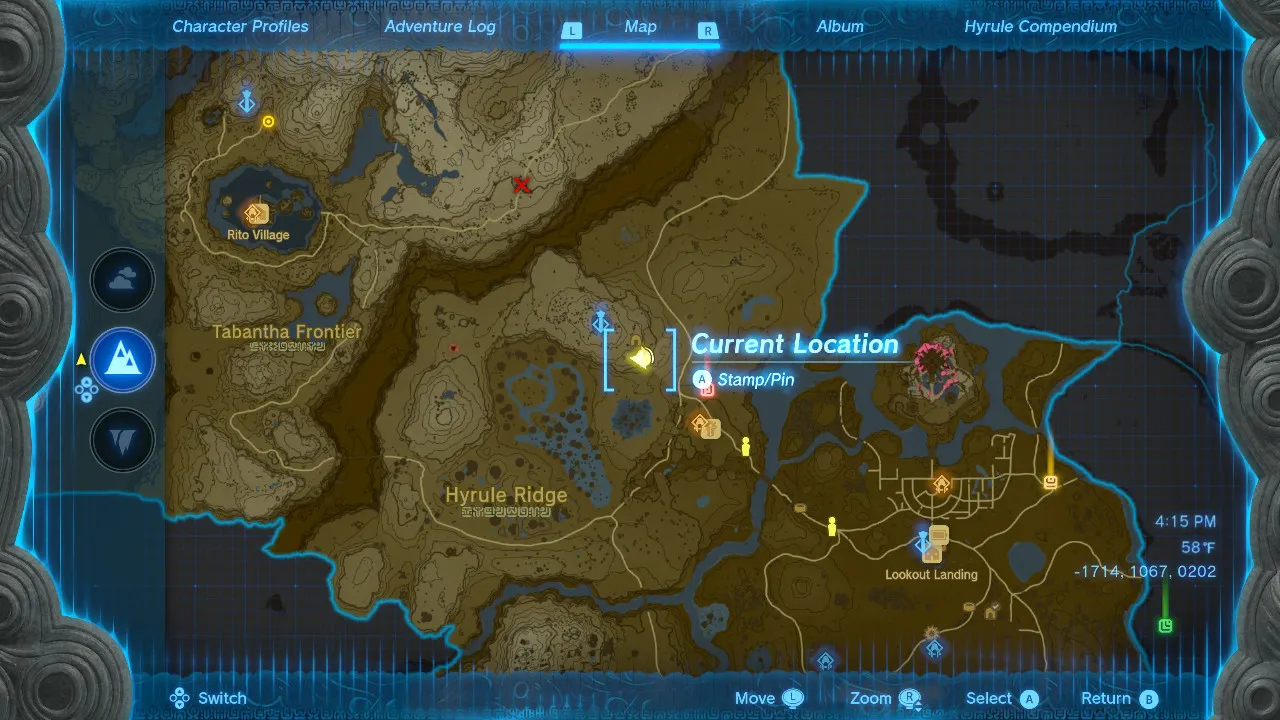Given my horse's location on this map, what is the quickest route to reach it? The quickest route to reach your horse is to head south, through the pass between the mountains, and then turn east. You will pass by the Tabantha Frontier and the Hyrule Ridge on your way. 